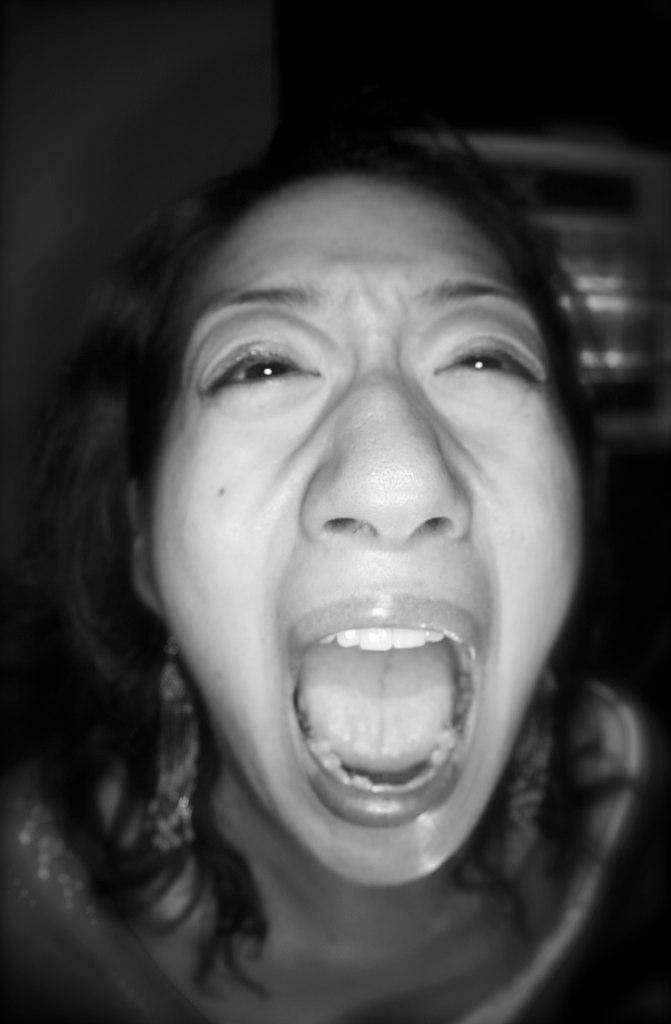What is the color scheme of the image? The image is black and white. Can you describe the main subject of the image? There is a lady in the image. What is the lady doing in the image? The lady has an opened mouth. What can be seen in the background of the image? The background of the image is dark. How many cents are visible on the lady's hand in the image? There are no cents visible in the image, as the image is black and white and does not contain any currency. 